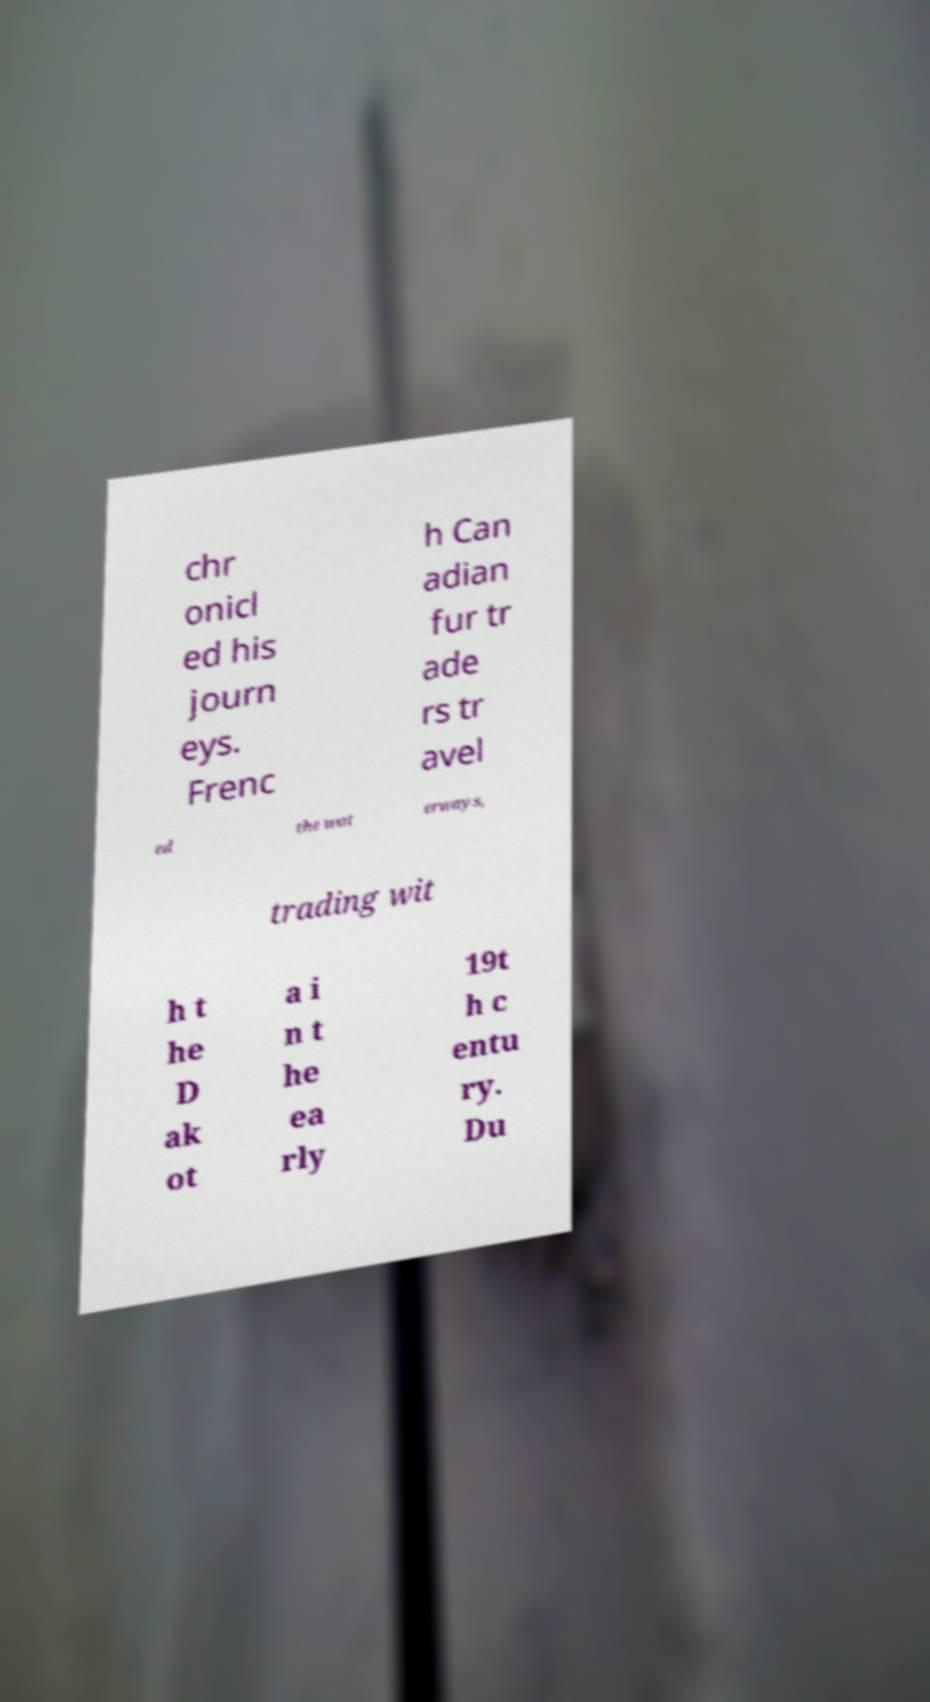I need the written content from this picture converted into text. Can you do that? chr onicl ed his journ eys. Frenc h Can adian fur tr ade rs tr avel ed the wat erways, trading wit h t he D ak ot a i n t he ea rly 19t h c entu ry. Du 